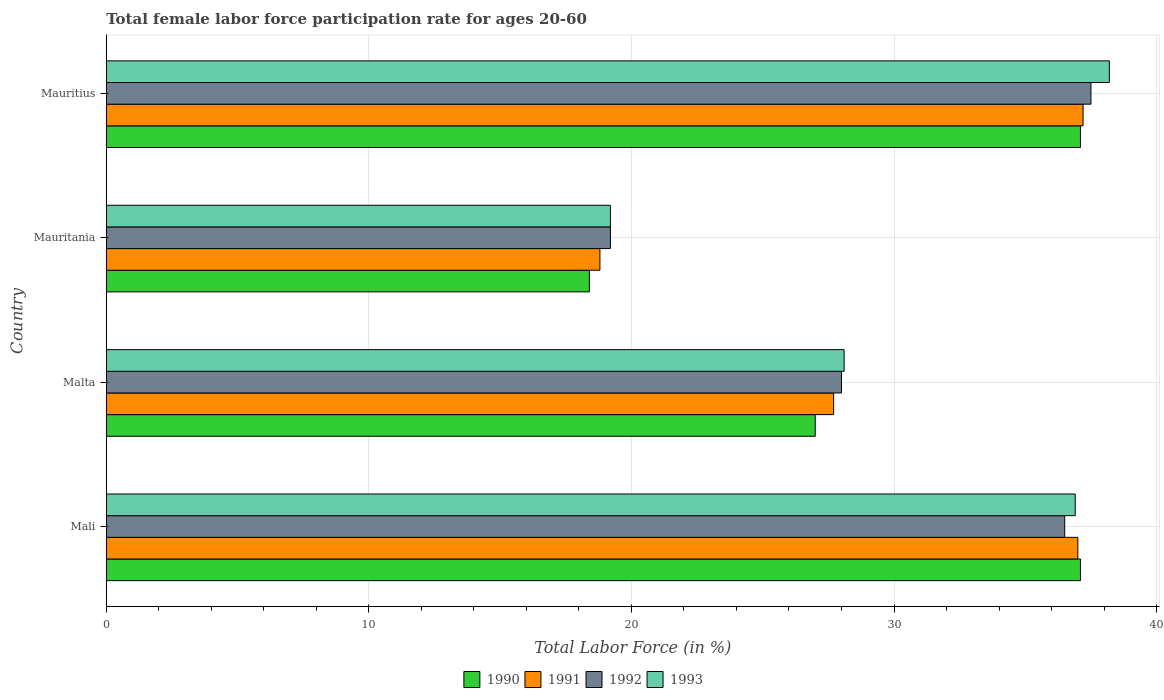How many groups of bars are there?
Your answer should be very brief. 4. What is the label of the 3rd group of bars from the top?
Make the answer very short. Malta. What is the female labor force participation rate in 1990 in Malta?
Make the answer very short. 27. Across all countries, what is the maximum female labor force participation rate in 1990?
Your response must be concise. 37.1. Across all countries, what is the minimum female labor force participation rate in 1992?
Give a very brief answer. 19.2. In which country was the female labor force participation rate in 1992 maximum?
Make the answer very short. Mauritius. In which country was the female labor force participation rate in 1993 minimum?
Keep it short and to the point. Mauritania. What is the total female labor force participation rate in 1992 in the graph?
Offer a very short reply. 121.2. What is the difference between the female labor force participation rate in 1993 in Mali and the female labor force participation rate in 1991 in Malta?
Offer a terse response. 9.2. What is the average female labor force participation rate in 1990 per country?
Provide a short and direct response. 29.9. What is the difference between the female labor force participation rate in 1993 and female labor force participation rate in 1990 in Mali?
Your answer should be compact. -0.2. What is the ratio of the female labor force participation rate in 1991 in Mauritania to that in Mauritius?
Make the answer very short. 0.51. Is the female labor force participation rate in 1992 in Mauritania less than that in Mauritius?
Ensure brevity in your answer.  Yes. Is the difference between the female labor force participation rate in 1993 in Mali and Malta greater than the difference between the female labor force participation rate in 1990 in Mali and Malta?
Offer a terse response. No. What is the difference between the highest and the second highest female labor force participation rate in 1993?
Give a very brief answer. 1.3. What is the difference between the highest and the lowest female labor force participation rate in 1992?
Ensure brevity in your answer.  18.3. Is the sum of the female labor force participation rate in 1992 in Mali and Malta greater than the maximum female labor force participation rate in 1991 across all countries?
Your answer should be very brief. Yes. Is it the case that in every country, the sum of the female labor force participation rate in 1990 and female labor force participation rate in 1992 is greater than the sum of female labor force participation rate in 1991 and female labor force participation rate in 1993?
Your answer should be compact. No. What does the 4th bar from the top in Mauritius represents?
Provide a short and direct response. 1990. Is it the case that in every country, the sum of the female labor force participation rate in 1993 and female labor force participation rate in 1991 is greater than the female labor force participation rate in 1990?
Provide a short and direct response. Yes. How many bars are there?
Offer a very short reply. 16. How many countries are there in the graph?
Your answer should be very brief. 4. Are the values on the major ticks of X-axis written in scientific E-notation?
Provide a succinct answer. No. Where does the legend appear in the graph?
Keep it short and to the point. Bottom center. What is the title of the graph?
Offer a terse response. Total female labor force participation rate for ages 20-60. What is the label or title of the Y-axis?
Provide a short and direct response. Country. What is the Total Labor Force (in %) of 1990 in Mali?
Offer a very short reply. 37.1. What is the Total Labor Force (in %) in 1991 in Mali?
Provide a succinct answer. 37. What is the Total Labor Force (in %) in 1992 in Mali?
Your answer should be very brief. 36.5. What is the Total Labor Force (in %) in 1993 in Mali?
Keep it short and to the point. 36.9. What is the Total Labor Force (in %) of 1991 in Malta?
Your answer should be compact. 27.7. What is the Total Labor Force (in %) in 1992 in Malta?
Give a very brief answer. 28. What is the Total Labor Force (in %) of 1993 in Malta?
Provide a short and direct response. 28.1. What is the Total Labor Force (in %) in 1990 in Mauritania?
Provide a succinct answer. 18.4. What is the Total Labor Force (in %) in 1991 in Mauritania?
Your response must be concise. 18.8. What is the Total Labor Force (in %) in 1992 in Mauritania?
Give a very brief answer. 19.2. What is the Total Labor Force (in %) of 1993 in Mauritania?
Offer a very short reply. 19.2. What is the Total Labor Force (in %) of 1990 in Mauritius?
Make the answer very short. 37.1. What is the Total Labor Force (in %) of 1991 in Mauritius?
Make the answer very short. 37.2. What is the Total Labor Force (in %) in 1992 in Mauritius?
Offer a very short reply. 37.5. What is the Total Labor Force (in %) of 1993 in Mauritius?
Your answer should be compact. 38.2. Across all countries, what is the maximum Total Labor Force (in %) in 1990?
Provide a succinct answer. 37.1. Across all countries, what is the maximum Total Labor Force (in %) in 1991?
Ensure brevity in your answer.  37.2. Across all countries, what is the maximum Total Labor Force (in %) in 1992?
Offer a very short reply. 37.5. Across all countries, what is the maximum Total Labor Force (in %) in 1993?
Make the answer very short. 38.2. Across all countries, what is the minimum Total Labor Force (in %) in 1990?
Your answer should be compact. 18.4. Across all countries, what is the minimum Total Labor Force (in %) of 1991?
Your answer should be compact. 18.8. Across all countries, what is the minimum Total Labor Force (in %) of 1992?
Keep it short and to the point. 19.2. Across all countries, what is the minimum Total Labor Force (in %) of 1993?
Your answer should be very brief. 19.2. What is the total Total Labor Force (in %) of 1990 in the graph?
Your answer should be very brief. 119.6. What is the total Total Labor Force (in %) in 1991 in the graph?
Your answer should be compact. 120.7. What is the total Total Labor Force (in %) in 1992 in the graph?
Make the answer very short. 121.2. What is the total Total Labor Force (in %) in 1993 in the graph?
Ensure brevity in your answer.  122.4. What is the difference between the Total Labor Force (in %) of 1990 in Mali and that in Malta?
Give a very brief answer. 10.1. What is the difference between the Total Labor Force (in %) of 1991 in Mali and that in Malta?
Provide a short and direct response. 9.3. What is the difference between the Total Labor Force (in %) in 1990 in Mali and that in Mauritania?
Ensure brevity in your answer.  18.7. What is the difference between the Total Labor Force (in %) of 1991 in Mali and that in Mauritania?
Offer a terse response. 18.2. What is the difference between the Total Labor Force (in %) in 1993 in Mali and that in Mauritania?
Your answer should be very brief. 17.7. What is the difference between the Total Labor Force (in %) of 1991 in Mali and that in Mauritius?
Your response must be concise. -0.2. What is the difference between the Total Labor Force (in %) of 1992 in Mali and that in Mauritius?
Make the answer very short. -1. What is the difference between the Total Labor Force (in %) of 1990 in Malta and that in Mauritania?
Your answer should be compact. 8.6. What is the difference between the Total Labor Force (in %) in 1991 in Malta and that in Mauritania?
Make the answer very short. 8.9. What is the difference between the Total Labor Force (in %) in 1992 in Malta and that in Mauritania?
Your response must be concise. 8.8. What is the difference between the Total Labor Force (in %) in 1991 in Malta and that in Mauritius?
Ensure brevity in your answer.  -9.5. What is the difference between the Total Labor Force (in %) of 1992 in Malta and that in Mauritius?
Give a very brief answer. -9.5. What is the difference between the Total Labor Force (in %) in 1990 in Mauritania and that in Mauritius?
Offer a very short reply. -18.7. What is the difference between the Total Labor Force (in %) of 1991 in Mauritania and that in Mauritius?
Offer a terse response. -18.4. What is the difference between the Total Labor Force (in %) of 1992 in Mauritania and that in Mauritius?
Your response must be concise. -18.3. What is the difference between the Total Labor Force (in %) in 1993 in Mauritania and that in Mauritius?
Provide a short and direct response. -19. What is the difference between the Total Labor Force (in %) in 1990 in Mali and the Total Labor Force (in %) in 1991 in Malta?
Your answer should be very brief. 9.4. What is the difference between the Total Labor Force (in %) in 1990 in Mali and the Total Labor Force (in %) in 1992 in Malta?
Offer a very short reply. 9.1. What is the difference between the Total Labor Force (in %) of 1990 in Mali and the Total Labor Force (in %) of 1991 in Mauritania?
Offer a very short reply. 18.3. What is the difference between the Total Labor Force (in %) in 1991 in Mali and the Total Labor Force (in %) in 1992 in Mauritania?
Give a very brief answer. 17.8. What is the difference between the Total Labor Force (in %) in 1991 in Mali and the Total Labor Force (in %) in 1993 in Mauritania?
Keep it short and to the point. 17.8. What is the difference between the Total Labor Force (in %) of 1990 in Mali and the Total Labor Force (in %) of 1991 in Mauritius?
Keep it short and to the point. -0.1. What is the difference between the Total Labor Force (in %) of 1990 in Mali and the Total Labor Force (in %) of 1992 in Mauritius?
Ensure brevity in your answer.  -0.4. What is the difference between the Total Labor Force (in %) in 1990 in Mali and the Total Labor Force (in %) in 1993 in Mauritius?
Offer a very short reply. -1.1. What is the difference between the Total Labor Force (in %) in 1990 in Malta and the Total Labor Force (in %) in 1991 in Mauritania?
Keep it short and to the point. 8.2. What is the difference between the Total Labor Force (in %) in 1990 in Malta and the Total Labor Force (in %) in 1993 in Mauritania?
Give a very brief answer. 7.8. What is the difference between the Total Labor Force (in %) in 1991 in Malta and the Total Labor Force (in %) in 1992 in Mauritania?
Your response must be concise. 8.5. What is the difference between the Total Labor Force (in %) in 1991 in Malta and the Total Labor Force (in %) in 1993 in Mauritania?
Your answer should be very brief. 8.5. What is the difference between the Total Labor Force (in %) in 1990 in Malta and the Total Labor Force (in %) in 1992 in Mauritius?
Your answer should be very brief. -10.5. What is the difference between the Total Labor Force (in %) of 1990 in Malta and the Total Labor Force (in %) of 1993 in Mauritius?
Offer a terse response. -11.2. What is the difference between the Total Labor Force (in %) in 1992 in Malta and the Total Labor Force (in %) in 1993 in Mauritius?
Offer a terse response. -10.2. What is the difference between the Total Labor Force (in %) of 1990 in Mauritania and the Total Labor Force (in %) of 1991 in Mauritius?
Keep it short and to the point. -18.8. What is the difference between the Total Labor Force (in %) of 1990 in Mauritania and the Total Labor Force (in %) of 1992 in Mauritius?
Give a very brief answer. -19.1. What is the difference between the Total Labor Force (in %) in 1990 in Mauritania and the Total Labor Force (in %) in 1993 in Mauritius?
Provide a short and direct response. -19.8. What is the difference between the Total Labor Force (in %) of 1991 in Mauritania and the Total Labor Force (in %) of 1992 in Mauritius?
Your answer should be compact. -18.7. What is the difference between the Total Labor Force (in %) in 1991 in Mauritania and the Total Labor Force (in %) in 1993 in Mauritius?
Provide a succinct answer. -19.4. What is the average Total Labor Force (in %) in 1990 per country?
Your answer should be very brief. 29.9. What is the average Total Labor Force (in %) of 1991 per country?
Your answer should be very brief. 30.18. What is the average Total Labor Force (in %) in 1992 per country?
Your response must be concise. 30.3. What is the average Total Labor Force (in %) in 1993 per country?
Offer a terse response. 30.6. What is the difference between the Total Labor Force (in %) in 1990 and Total Labor Force (in %) in 1991 in Mali?
Your answer should be very brief. 0.1. What is the difference between the Total Labor Force (in %) in 1990 and Total Labor Force (in %) in 1993 in Mali?
Ensure brevity in your answer.  0.2. What is the difference between the Total Labor Force (in %) in 1990 and Total Labor Force (in %) in 1991 in Malta?
Your answer should be very brief. -0.7. What is the difference between the Total Labor Force (in %) in 1990 and Total Labor Force (in %) in 1992 in Malta?
Your answer should be very brief. -1. What is the difference between the Total Labor Force (in %) of 1991 and Total Labor Force (in %) of 1993 in Malta?
Your answer should be very brief. -0.4. What is the difference between the Total Labor Force (in %) of 1992 and Total Labor Force (in %) of 1993 in Malta?
Provide a succinct answer. -0.1. What is the difference between the Total Labor Force (in %) in 1990 and Total Labor Force (in %) in 1991 in Mauritania?
Provide a succinct answer. -0.4. What is the difference between the Total Labor Force (in %) in 1990 and Total Labor Force (in %) in 1993 in Mauritania?
Ensure brevity in your answer.  -0.8. What is the difference between the Total Labor Force (in %) of 1991 and Total Labor Force (in %) of 1992 in Mauritania?
Your response must be concise. -0.4. What is the difference between the Total Labor Force (in %) of 1991 and Total Labor Force (in %) of 1993 in Mauritania?
Provide a succinct answer. -0.4. What is the difference between the Total Labor Force (in %) in 1992 and Total Labor Force (in %) in 1993 in Mauritania?
Offer a terse response. 0. What is the difference between the Total Labor Force (in %) in 1990 and Total Labor Force (in %) in 1992 in Mauritius?
Give a very brief answer. -0.4. What is the difference between the Total Labor Force (in %) of 1990 and Total Labor Force (in %) of 1993 in Mauritius?
Offer a very short reply. -1.1. What is the difference between the Total Labor Force (in %) of 1991 and Total Labor Force (in %) of 1993 in Mauritius?
Your response must be concise. -1. What is the ratio of the Total Labor Force (in %) in 1990 in Mali to that in Malta?
Provide a succinct answer. 1.37. What is the ratio of the Total Labor Force (in %) of 1991 in Mali to that in Malta?
Offer a terse response. 1.34. What is the ratio of the Total Labor Force (in %) in 1992 in Mali to that in Malta?
Your answer should be compact. 1.3. What is the ratio of the Total Labor Force (in %) of 1993 in Mali to that in Malta?
Ensure brevity in your answer.  1.31. What is the ratio of the Total Labor Force (in %) in 1990 in Mali to that in Mauritania?
Your answer should be very brief. 2.02. What is the ratio of the Total Labor Force (in %) of 1991 in Mali to that in Mauritania?
Offer a terse response. 1.97. What is the ratio of the Total Labor Force (in %) in 1992 in Mali to that in Mauritania?
Provide a succinct answer. 1.9. What is the ratio of the Total Labor Force (in %) of 1993 in Mali to that in Mauritania?
Offer a very short reply. 1.92. What is the ratio of the Total Labor Force (in %) in 1992 in Mali to that in Mauritius?
Provide a short and direct response. 0.97. What is the ratio of the Total Labor Force (in %) in 1990 in Malta to that in Mauritania?
Offer a very short reply. 1.47. What is the ratio of the Total Labor Force (in %) of 1991 in Malta to that in Mauritania?
Provide a short and direct response. 1.47. What is the ratio of the Total Labor Force (in %) in 1992 in Malta to that in Mauritania?
Make the answer very short. 1.46. What is the ratio of the Total Labor Force (in %) in 1993 in Malta to that in Mauritania?
Make the answer very short. 1.46. What is the ratio of the Total Labor Force (in %) in 1990 in Malta to that in Mauritius?
Offer a very short reply. 0.73. What is the ratio of the Total Labor Force (in %) of 1991 in Malta to that in Mauritius?
Ensure brevity in your answer.  0.74. What is the ratio of the Total Labor Force (in %) of 1992 in Malta to that in Mauritius?
Provide a short and direct response. 0.75. What is the ratio of the Total Labor Force (in %) in 1993 in Malta to that in Mauritius?
Your answer should be very brief. 0.74. What is the ratio of the Total Labor Force (in %) in 1990 in Mauritania to that in Mauritius?
Offer a very short reply. 0.5. What is the ratio of the Total Labor Force (in %) in 1991 in Mauritania to that in Mauritius?
Provide a succinct answer. 0.51. What is the ratio of the Total Labor Force (in %) of 1992 in Mauritania to that in Mauritius?
Offer a terse response. 0.51. What is the ratio of the Total Labor Force (in %) in 1993 in Mauritania to that in Mauritius?
Keep it short and to the point. 0.5. What is the difference between the highest and the lowest Total Labor Force (in %) of 1993?
Keep it short and to the point. 19. 